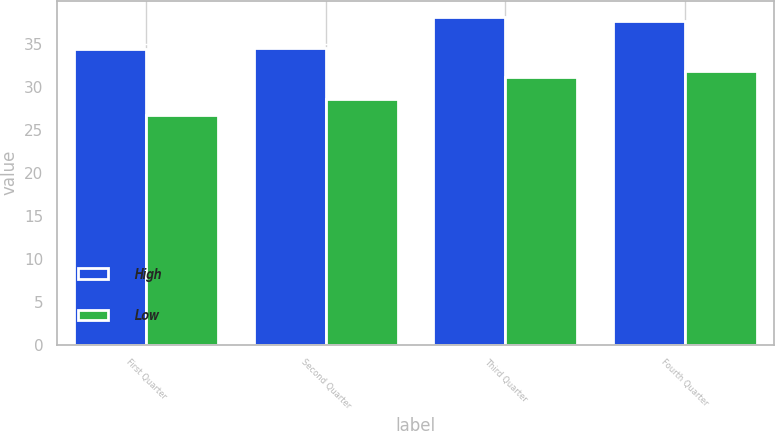Convert chart to OTSL. <chart><loc_0><loc_0><loc_500><loc_500><stacked_bar_chart><ecel><fcel>First Quarter<fcel>Second Quarter<fcel>Third Quarter<fcel>Fourth Quarter<nl><fcel>High<fcel>34.37<fcel>34.5<fcel>38.05<fcel>37.65<nl><fcel>Low<fcel>26.7<fcel>28.53<fcel>31.08<fcel>31.87<nl></chart> 